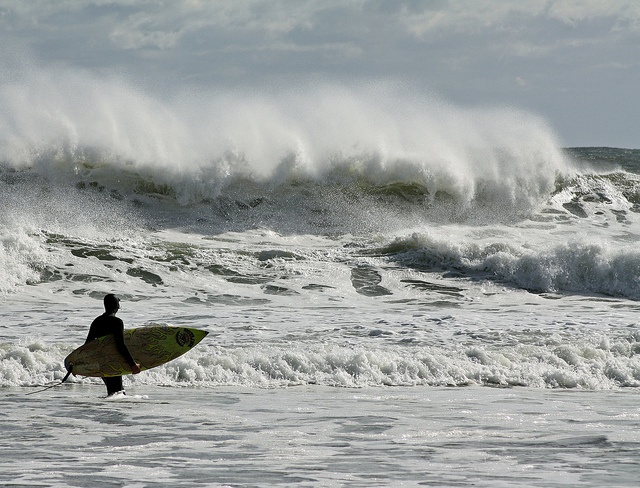Describe the objects in this image and their specific colors. I can see surfboard in darkgray, black, darkgreen, and lightgray tones and people in darkgray, black, gray, and lightgray tones in this image. 